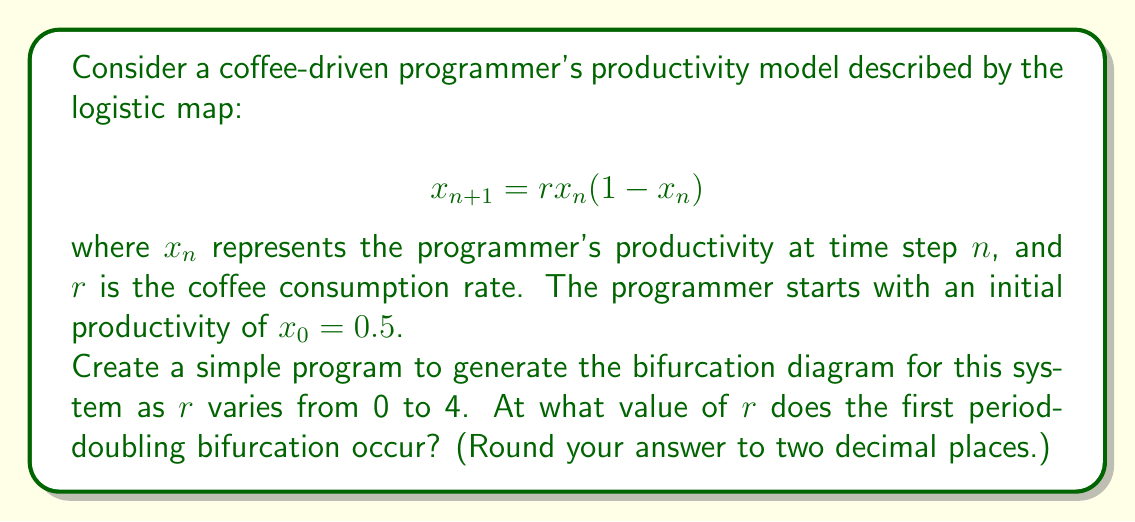Solve this math problem. To solve this problem, we need to follow these steps:

1) Understand the logistic map:
   The equation $x_{n+1} = rx_n(1-x_n)$ models the programmer's productivity over time, where $r$ represents the coffee consumption rate.

2) Create a program to generate the bifurcation diagram:
   - Iterate the map for different values of $r$ from 0 to 4.
   - For each $r$, calculate and plot the stable states after some initial transients.

3) Identify the first period-doubling bifurcation:
   - As $r$ increases, the system first has a single stable fixed point.
   - The first bifurcation occurs when this single point splits into two points.

4) Determine the $r$ value at the first bifurcation:
   - This occurs when $\left|\frac{d}{dx}(rx(1-x))\right| = 1$ at the fixed point.
   - The fixed point is given by $x^* = 1 - \frac{1}{r}$.
   - Solving:
     $$ \left|r(1-2x^*)\right| = 1 $$
     $$ \left|r(1-2(1-\frac{1}{r}))\right| = 1 $$
     $$ \left|r(-1+\frac{2}{r})\right| = 1 $$
     $$ |-r+2| = 1 $$

5) Solve the equation:
   $-r+2 = 1$ or $-r+2 = -1$
   $r = 1$ or $r = 3$

   The first bifurcation occurs at $r = 3$.

Therefore, the first period-doubling bifurcation occurs at $r = 3.00$.
Answer: 3.00 